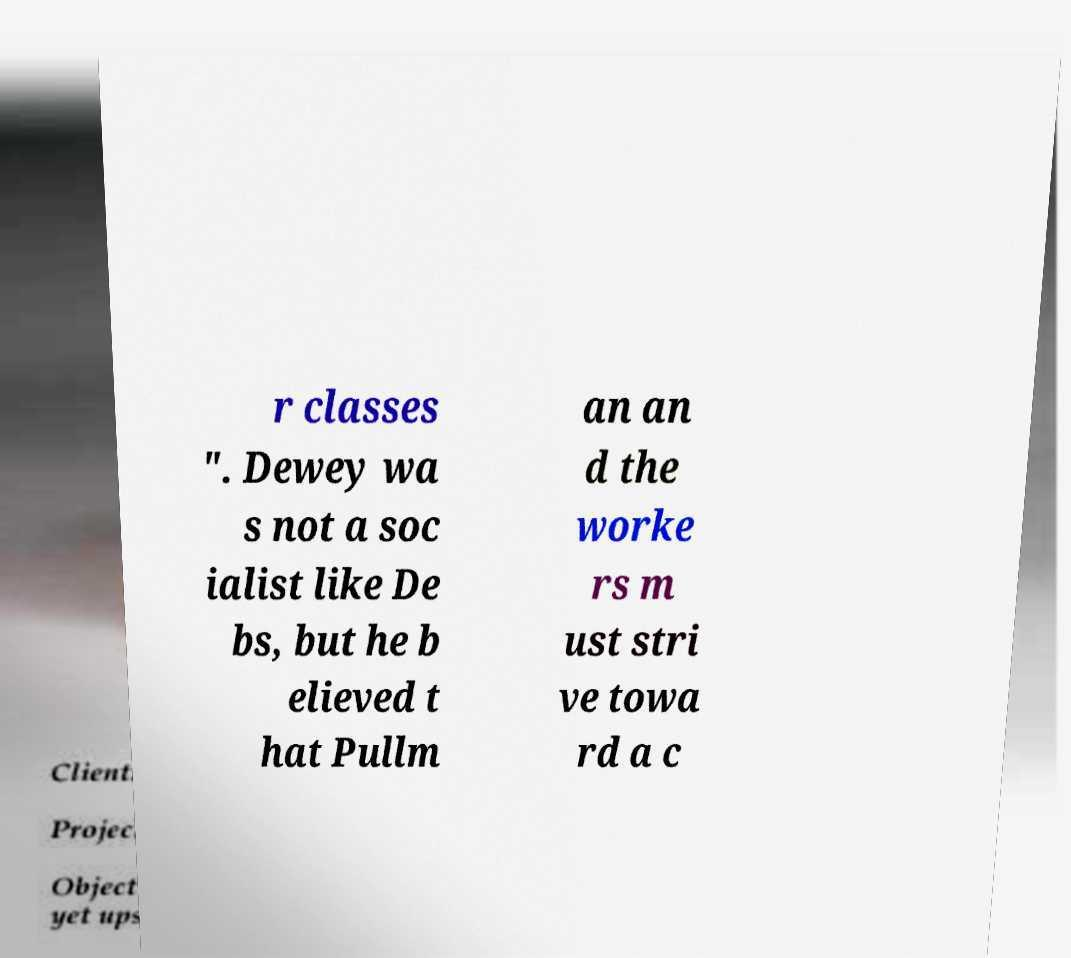I need the written content from this picture converted into text. Can you do that? r classes ". Dewey wa s not a soc ialist like De bs, but he b elieved t hat Pullm an an d the worke rs m ust stri ve towa rd a c 